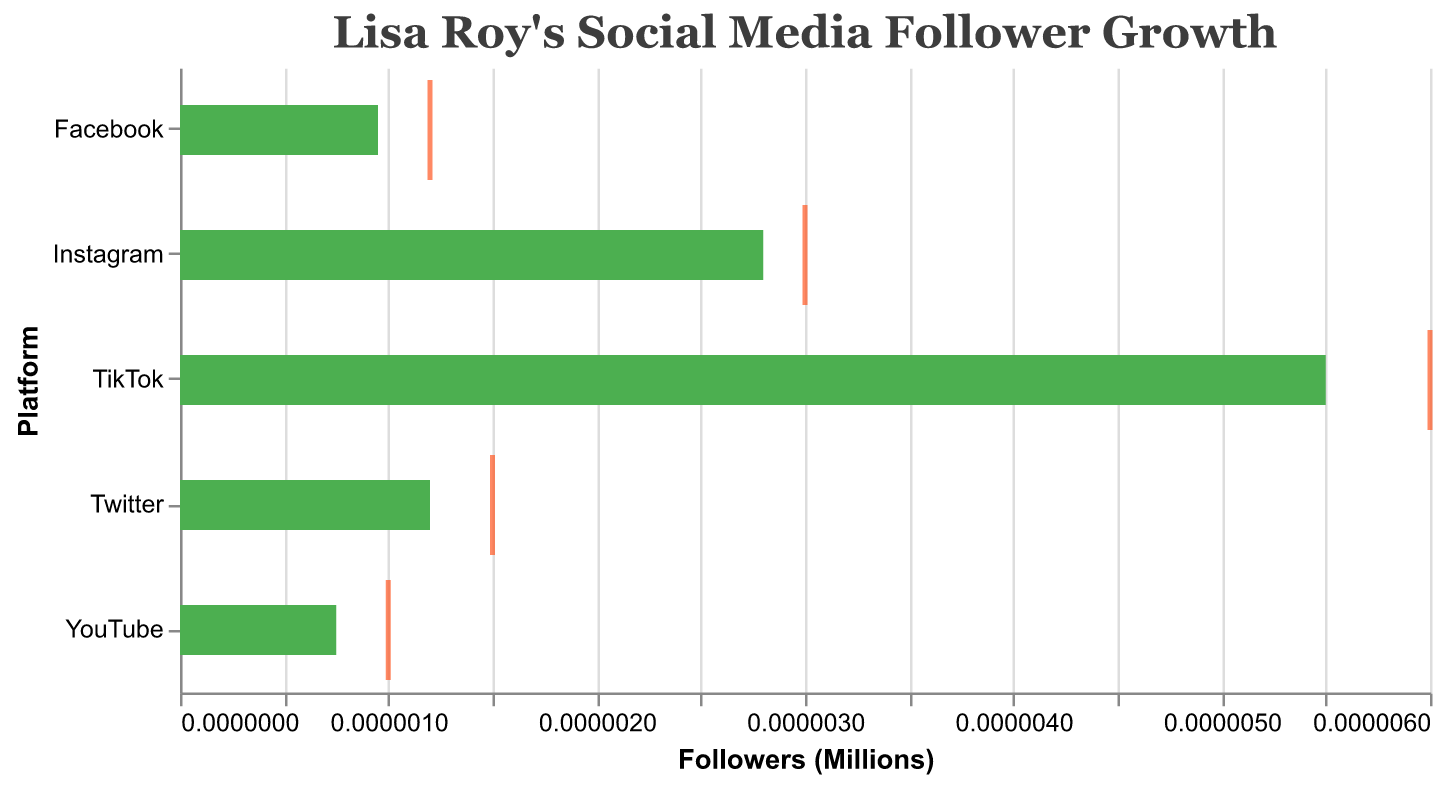How many social media platforms are shown in the figure? Count the number of different platforms on the Y-axis. There are Instagram, Twitter, TikTok, Facebook, and YouTube.
Answer: 5 What is the title of the figure? Look at the title text at the top of the chart.
Answer: Lisa Roy's Social Media Follower Growth Which platform has the highest number of actual followers? Identify the longest green bar on the chart, which represents actual followers. TikTok has the longest green bar indicating the highest number of actual followers at 5.5 million.
Answer: TikTok By how much does Instagram's actual follower count exceed its benchmark? Subtract Instagram's benchmark (1.5M) from its actual followers (2.8M): 2.8M - 1.5M = 1.3M.
Answer: 1.3M For which platforms does Lisa Roy's actual follower count meet or exceed the industry benchmark? Compare the lengths of the green bars (actual) with the gray bars (benchmark). Instagram (2.8M vs. 1.5M), Twitter (1.2M vs. 0.8M), TikTok (5.5M vs. 3M), Facebook (0.95M vs. 0.7M), and YouTube (0.75M vs. 0.5M); for all platforms, the actual count is higher than the benchmark.
Answer: All platforms By how much does TikTok's actual follower count fall short of its target? Subtract TikTok's actual followers (5.5M) from its target (6M): 6M - 5.5M = 0.5M.
Answer: 0.5M Which platform has the smallest gap between actual and target follower counts? Calculate the difference between the actual and target for each platform, then identify the smallest: Instagram (3M - 2.8M = 0.2M), Twitter (1.5M - 1.2M = 0.3M), TikTok (6M - 5.5M = 0.5M), Facebook (1.2M - 0.95M = 0.25M), YouTube (1M - 0.75M = 0.25M). Instagram has the smallest gap.
Answer: Instagram Which platform shows the largest difference between the actual follower count and the benchmark? Calculate the difference for each platform and identify the largest: Instagram (2.8M - 1.5M = 1.3M), Twitter (1.2M - 0.8M = 0.4M), TikTok (5.5M - 3M = 2.5M), Facebook (0.95M - 0.7M = 0.25M), YouTube (0.75M - 0.5M = 0.25M). TikTok has the largest difference of 2.5M.
Answer: TikTok Is there any platform where Lisa Roy’s actual followers surpass the target? Compare the lengths of the green bars (actual) against the red tick marks (target). No platform shows actual followers surpassing the target.
Answer: No 